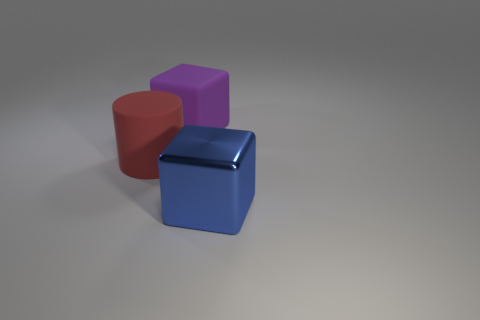Could you speculate on the weight differences between these objects? Given that the cube is metal and the other two objects are rubber, the blue cube likely weighs more than the red cylinder and the purple cube, despite being of similar size. Metal generally has a higher density than rubber, resulting in a greater mass for the same volume. 